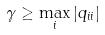<formula> <loc_0><loc_0><loc_500><loc_500>\gamma \geq \max _ { i } | q _ { i i } |</formula> 